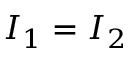Convert formula to latex. <formula><loc_0><loc_0><loc_500><loc_500>I _ { 1 } = I _ { 2 }</formula> 